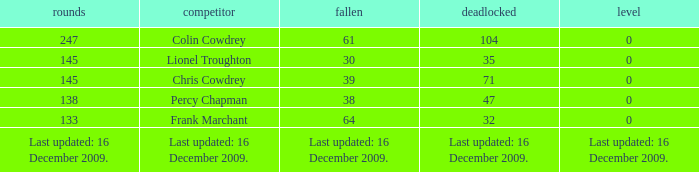Name the tie that has 71 drawn 0.0. Can you give me this table as a dict? {'header': ['rounds', 'competitor', 'fallen', 'deadlocked', 'level'], 'rows': [['247', 'Colin Cowdrey', '61', '104', '0'], ['145', 'Lionel Troughton', '30', '35', '0'], ['145', 'Chris Cowdrey', '39', '71', '0'], ['138', 'Percy Chapman', '38', '47', '0'], ['133', 'Frank Marchant', '64', '32', '0'], ['Last updated: 16 December 2009.', 'Last updated: 16 December 2009.', 'Last updated: 16 December 2009.', 'Last updated: 16 December 2009.', 'Last updated: 16 December 2009.']]} 